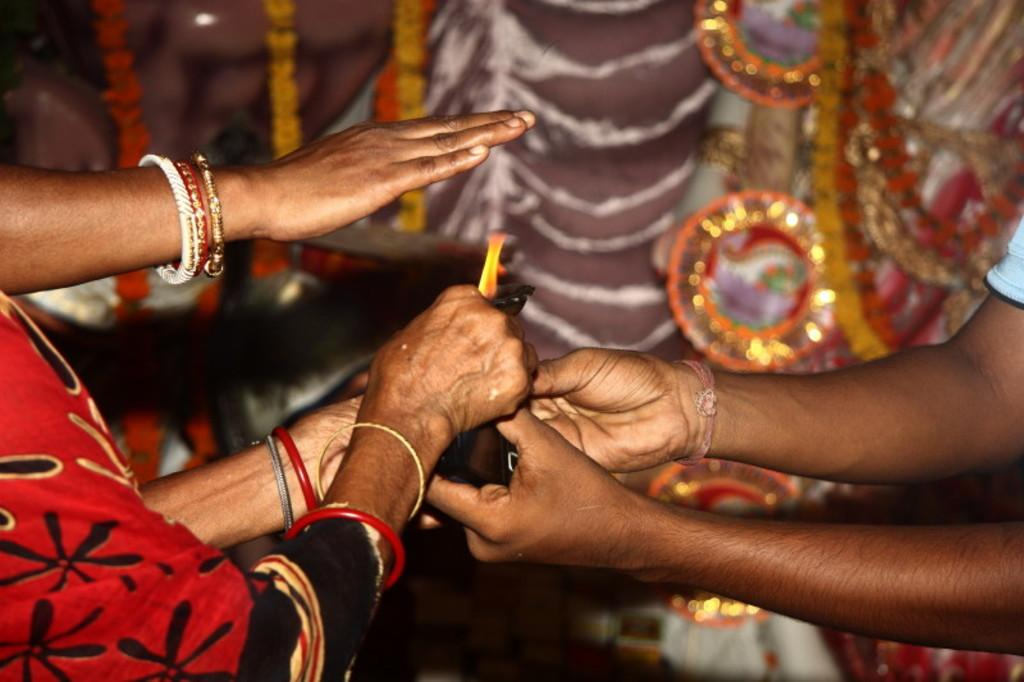What can be seen in the image involving the hands of people? There are hands of a few people in the image. What is a person doing with their hands in the image? A person is holding an object in the image. What is the nature of the object being held? There is a flame on the object. What can be seen in the background of the image? There are garlands and a curtain on the wall in the background of the image. Can you see a yoke being used by the people in the image? There is no yoke present in the image. Is there a hill visible in the background of the image? There is no hill visible in the image; only garlands and a curtain on the wall are present in the background. 